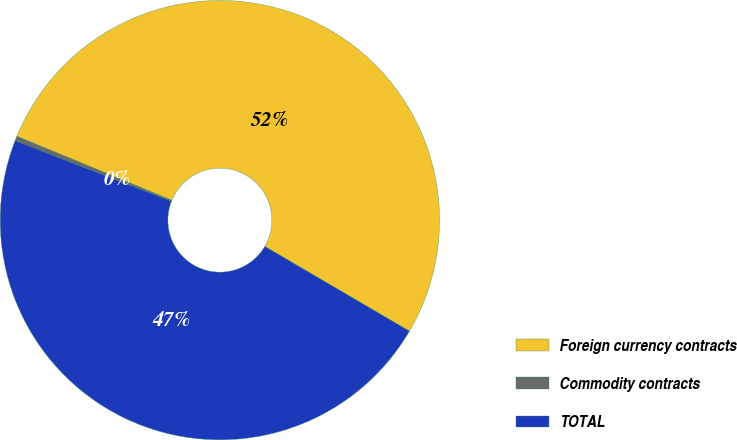Convert chart to OTSL. <chart><loc_0><loc_0><loc_500><loc_500><pie_chart><fcel>Foreign currency contracts<fcel>Commodity contracts<fcel>TOTAL<nl><fcel>52.2%<fcel>0.34%<fcel>47.46%<nl></chart> 